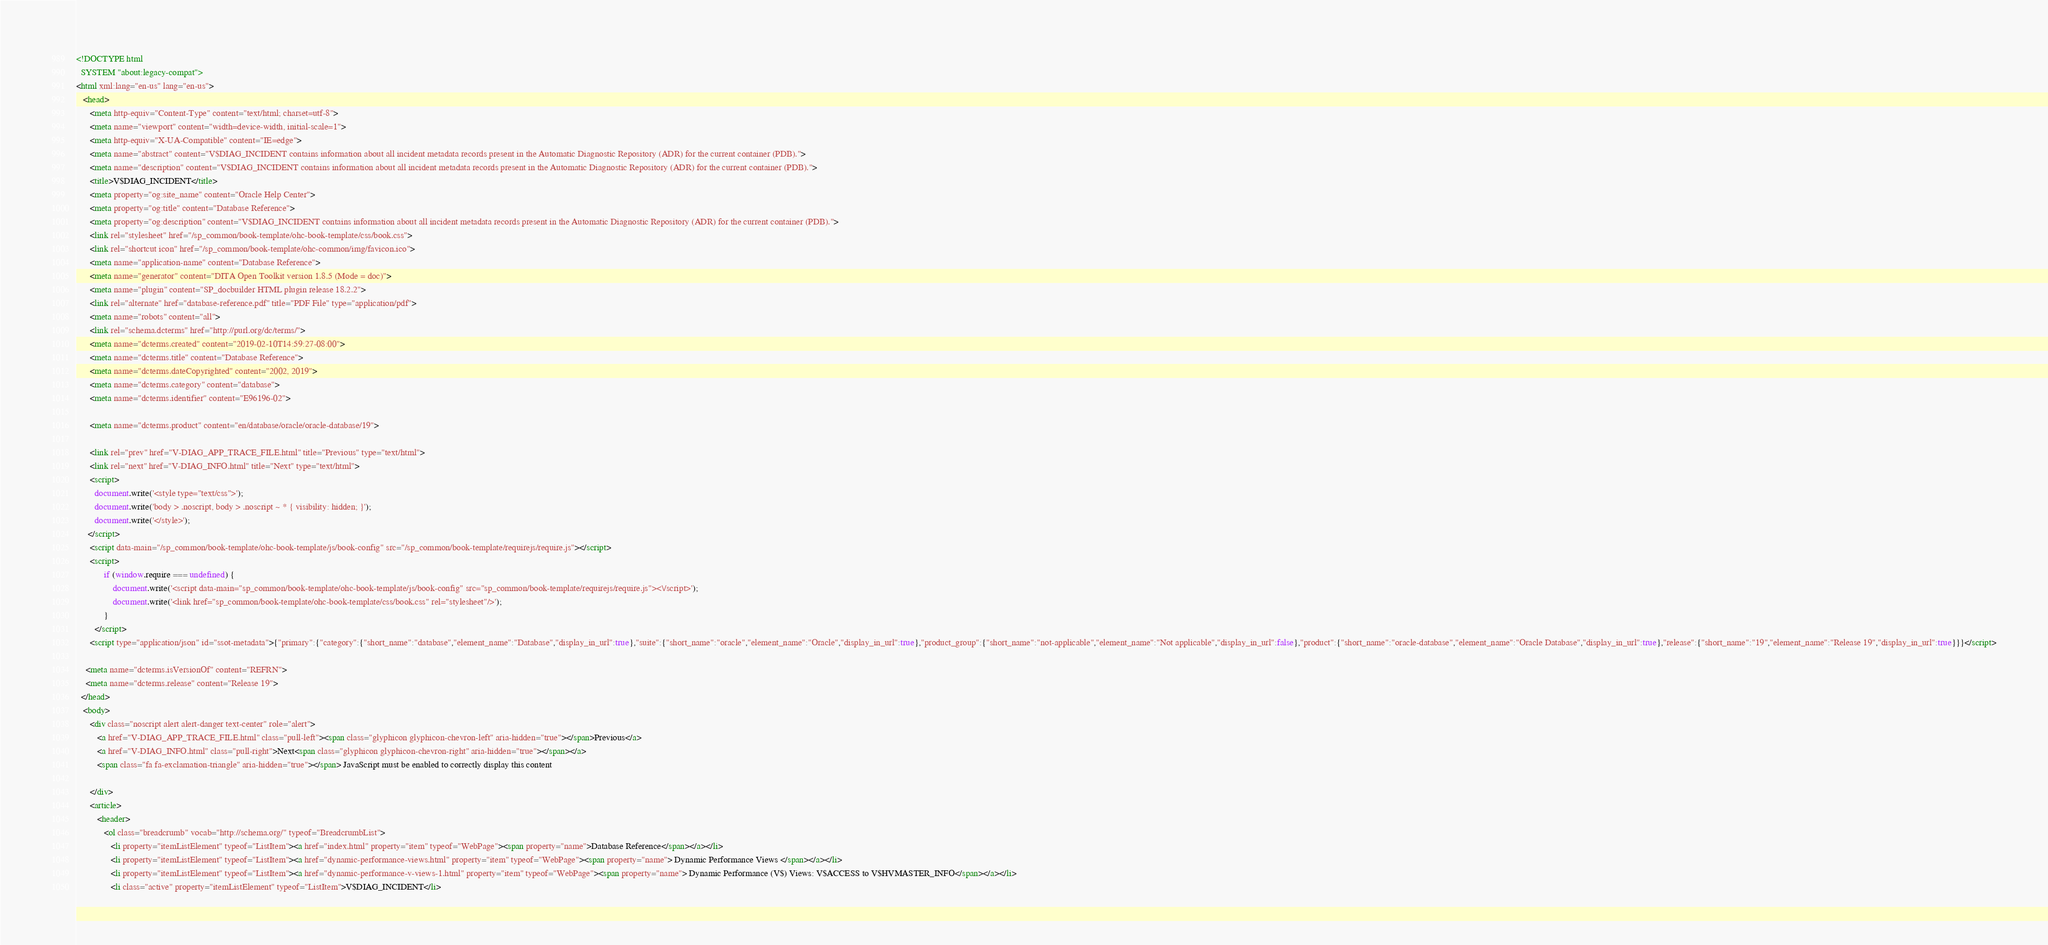Convert code to text. <code><loc_0><loc_0><loc_500><loc_500><_HTML_><!DOCTYPE html
  SYSTEM "about:legacy-compat">
<html xml:lang="en-us" lang="en-us">
   <head>
      <meta http-equiv="Content-Type" content="text/html; charset=utf-8">
      <meta name="viewport" content="width=device-width, initial-scale=1">
      <meta http-equiv="X-UA-Compatible" content="IE=edge">
      <meta name="abstract" content="V$DIAG_INCIDENT contains information about all incident metadata records present in the Automatic Diagnostic Repository (ADR) for the current container (PDB).">
      <meta name="description" content="V$DIAG_INCIDENT contains information about all incident metadata records present in the Automatic Diagnostic Repository (ADR) for the current container (PDB).">
      <title>V$DIAG_INCIDENT</title>
      <meta property="og:site_name" content="Oracle Help Center">
      <meta property="og:title" content="Database Reference">
      <meta property="og:description" content="V$DIAG_INCIDENT contains information about all incident metadata records present in the Automatic Diagnostic Repository (ADR) for the current container (PDB).">
      <link rel="stylesheet" href="/sp_common/book-template/ohc-book-template/css/book.css">
      <link rel="shortcut icon" href="/sp_common/book-template/ohc-common/img/favicon.ico">
      <meta name="application-name" content="Database Reference">
      <meta name="generator" content="DITA Open Toolkit version 1.8.5 (Mode = doc)">
      <meta name="plugin" content="SP_docbuilder HTML plugin release 18.2.2">
      <link rel="alternate" href="database-reference.pdf" title="PDF File" type="application/pdf">
      <meta name="robots" content="all">
      <link rel="schema.dcterms" href="http://purl.org/dc/terms/">
      <meta name="dcterms.created" content="2019-02-10T14:59:27-08:00">
      <meta name="dcterms.title" content="Database Reference">
      <meta name="dcterms.dateCopyrighted" content="2002, 2019">
      <meta name="dcterms.category" content="database">
      <meta name="dcterms.identifier" content="E96196-02">
      
      <meta name="dcterms.product" content="en/database/oracle/oracle-database/19">
      
      <link rel="prev" href="V-DIAG_APP_TRACE_FILE.html" title="Previous" type="text/html">
      <link rel="next" href="V-DIAG_INFO.html" title="Next" type="text/html">
      <script>
        document.write('<style type="text/css">');
        document.write('body > .noscript, body > .noscript ~ * { visibility: hidden; }');
        document.write('</style>');
     </script>
      <script data-main="/sp_common/book-template/ohc-book-template/js/book-config" src="/sp_common/book-template/requirejs/require.js"></script>
      <script>
            if (window.require === undefined) {
                document.write('<script data-main="sp_common/book-template/ohc-book-template/js/book-config" src="sp_common/book-template/requirejs/require.js"><\/script>');
                document.write('<link href="sp_common/book-template/ohc-book-template/css/book.css" rel="stylesheet"/>');
            }
        </script>
      <script type="application/json" id="ssot-metadata">{"primary":{"category":{"short_name":"database","element_name":"Database","display_in_url":true},"suite":{"short_name":"oracle","element_name":"Oracle","display_in_url":true},"product_group":{"short_name":"not-applicable","element_name":"Not applicable","display_in_url":false},"product":{"short_name":"oracle-database","element_name":"Oracle Database","display_in_url":true},"release":{"short_name":"19","element_name":"Release 19","display_in_url":true}}}</script>
      
    <meta name="dcterms.isVersionOf" content="REFRN">
    <meta name="dcterms.release" content="Release 19">
  </head>
   <body>
      <div class="noscript alert alert-danger text-center" role="alert">
         <a href="V-DIAG_APP_TRACE_FILE.html" class="pull-left"><span class="glyphicon glyphicon-chevron-left" aria-hidden="true"></span>Previous</a>
         <a href="V-DIAG_INFO.html" class="pull-right">Next<span class="glyphicon glyphicon-chevron-right" aria-hidden="true"></span></a>
         <span class="fa fa-exclamation-triangle" aria-hidden="true"></span> JavaScript must be enabled to correctly display this content
        
      </div>
      <article>
         <header>
            <ol class="breadcrumb" vocab="http://schema.org/" typeof="BreadcrumbList">
               <li property="itemListElement" typeof="ListItem"><a href="index.html" property="item" typeof="WebPage"><span property="name">Database Reference</span></a></li>
               <li property="itemListElement" typeof="ListItem"><a href="dynamic-performance-views.html" property="item" typeof="WebPage"><span property="name"> Dynamic Performance Views </span></a></li>
               <li property="itemListElement" typeof="ListItem"><a href="dynamic-performance-v-views-1.html" property="item" typeof="WebPage"><span property="name"> Dynamic Performance (V$) Views: V$ACCESS to V$HVMASTER_INFO</span></a></li>
               <li class="active" property="itemListElement" typeof="ListItem">V$DIAG_INCIDENT</li></code> 